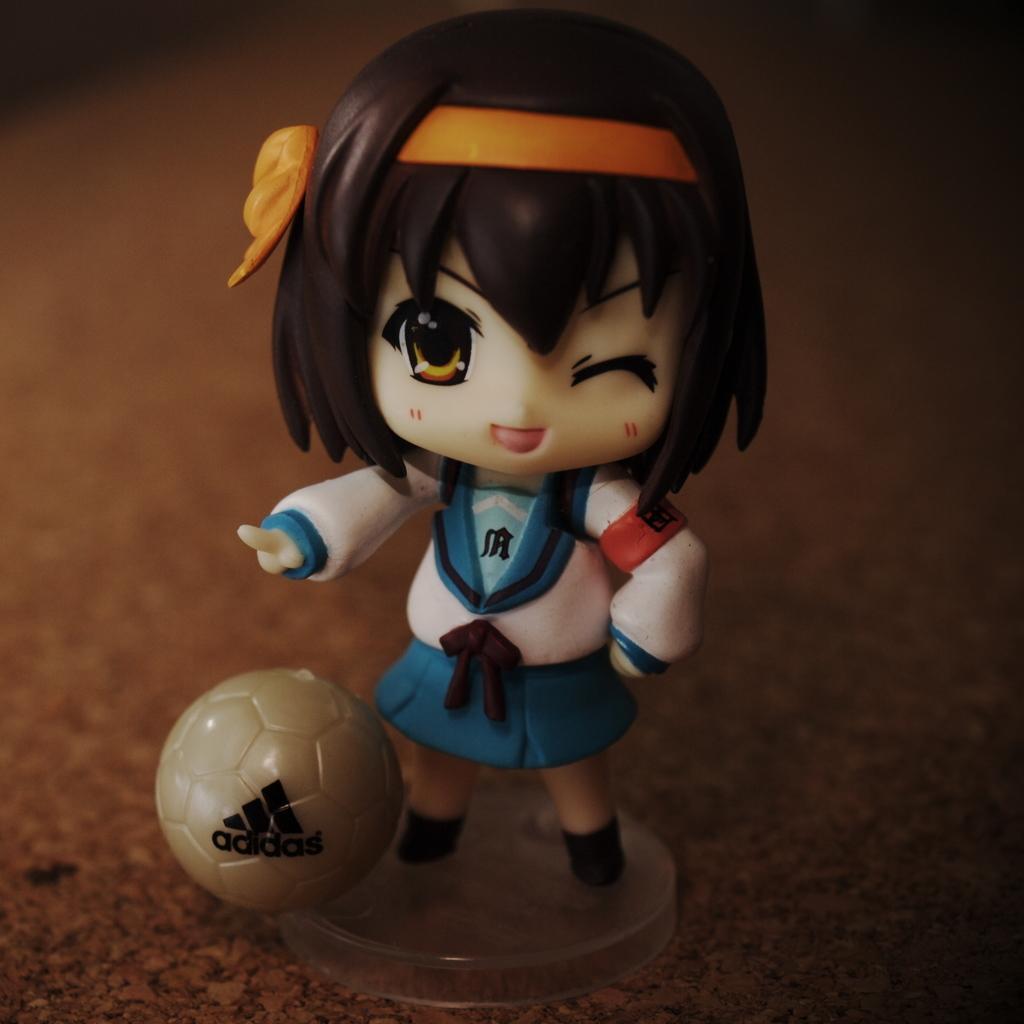In one or two sentences, can you explain what this image depicts? In this image I can see a toy girl wearing white and blue color dress, in front I can see a ball in brown color and I can see a brown color background. 